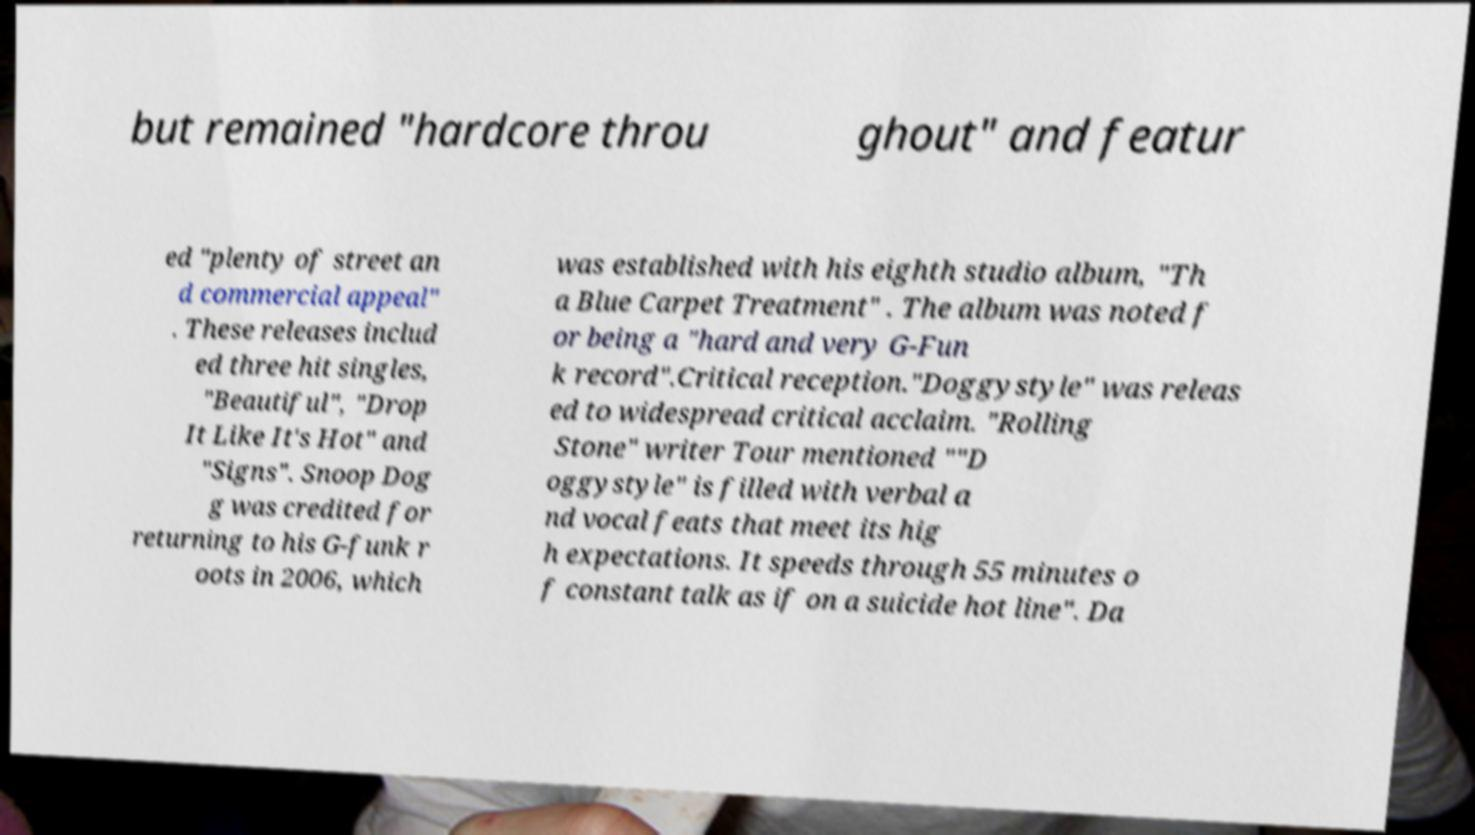Could you extract and type out the text from this image? but remained "hardcore throu ghout" and featur ed "plenty of street an d commercial appeal" . These releases includ ed three hit singles, "Beautiful", "Drop It Like It's Hot" and "Signs". Snoop Dog g was credited for returning to his G-funk r oots in 2006, which was established with his eighth studio album, "Th a Blue Carpet Treatment" . The album was noted f or being a "hard and very G-Fun k record".Critical reception."Doggystyle" was releas ed to widespread critical acclaim. "Rolling Stone" writer Tour mentioned ""D oggystyle" is filled with verbal a nd vocal feats that meet its hig h expectations. It speeds through 55 minutes o f constant talk as if on a suicide hot line". Da 